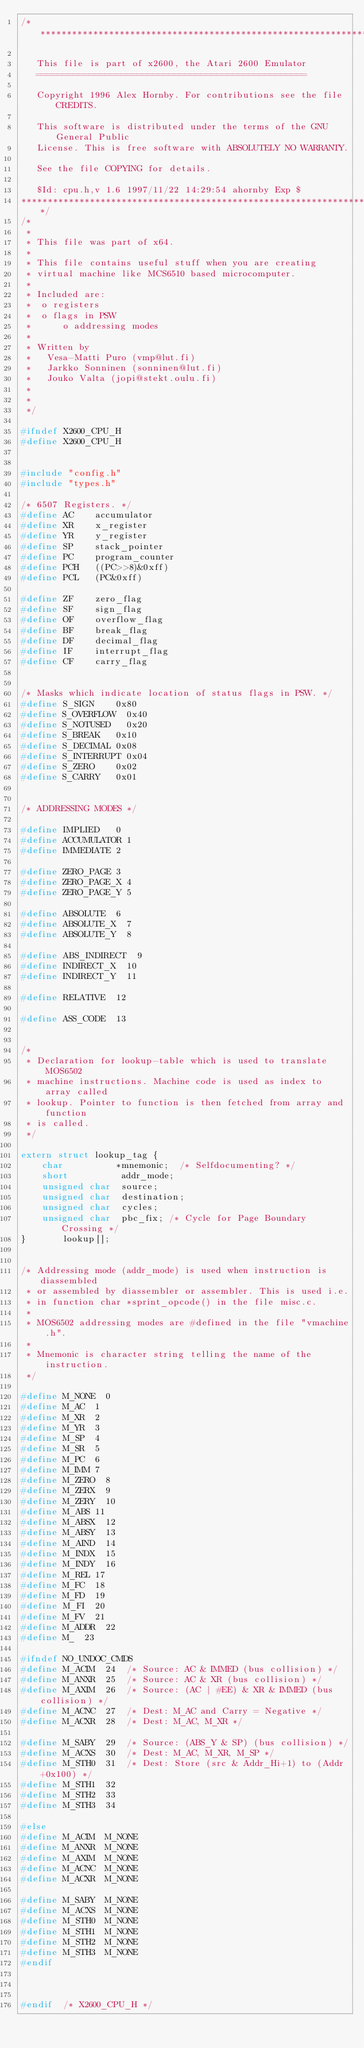Convert code to text. <code><loc_0><loc_0><loc_500><loc_500><_C_>/*****************************************************************************

   This file is part of x2600, the Atari 2600 Emulator
   ===================================================
   
   Copyright 1996 Alex Hornby. For contributions see the file CREDITS.

   This software is distributed under the terms of the GNU General Public
   License. This is free software with ABSOLUTELY NO WARRANTY.
   
   See the file COPYING for details.
   
   $Id: cpu.h,v 1.6 1997/11/22 14:29:54 ahornby Exp $
******************************************************************************/
/*
 *
 * This file was part of x64.
 *
 * This file contains useful stuff when you are creating
 * virtual machine like MCS6510 based microcomputer.
 *
 * Included are:
 *	o registers
 *	o flags in PSW
 *      o addressing modes
 *
 * Written by
 *   Vesa-Matti Puro (vmp@lut.fi)
 *   Jarkko Sonninen (sonninen@lut.fi)
 *   Jouko Valta (jopi@stekt.oulu.fi)
 *
 *
 */

#ifndef X2600_CPU_H
#define X2600_CPU_H


#include "config.h"
#include "types.h"

/* 6507 Registers. */
#define AC		accumulator
#define XR		x_register
#define YR		y_register
#define SP		stack_pointer
#define PC		program_counter
#define PCH		((PC>>8)&0xff)
#define PCL		(PC&0xff)

#define ZF		zero_flag
#define SF		sign_flag
#define OF		overflow_flag
#define BF		break_flag
#define DF		decimal_flag
#define IF		interrupt_flag
#define CF		carry_flag


/* Masks which indicate location of status flags in PSW. */
#define S_SIGN		0x80
#define S_OVERFLOW	0x40
#define S_NOTUSED 	0x20
#define S_BREAK		0x10
#define S_DECIMAL	0x08
#define S_INTERRUPT	0x04
#define S_ZERO		0x02
#define S_CARRY		0x01


/* ADDRESSING MODES */

#define IMPLIED		0
#define ACCUMULATOR	1
#define IMMEDIATE	2

#define ZERO_PAGE	3
#define ZERO_PAGE_X	4
#define ZERO_PAGE_Y	5

#define ABSOLUTE	6
#define ABSOLUTE_X	7
#define ABSOLUTE_Y	8

#define ABS_INDIRECT	9
#define INDIRECT_X	10
#define INDIRECT_Y	11

#define RELATIVE	12

#define ASS_CODE	13


/*
 * Declaration for lookup-table which is used to translate MOS6502
 * machine instructions. Machine code is used as index to array called
 * lookup. Pointer to function is then fetched from array and function
 * is called.
 */

extern struct lookup_tag {
    char          *mnemonic;	/* Selfdocumenting? */
    short          addr_mode;
    unsigned char  source;
    unsigned char  destination;
    unsigned char  cycles;
    unsigned char  pbc_fix;	/* Cycle for Page Boundary Crossing */
}       lookup[];


/* Addressing mode (addr_mode) is used when instruction is diassembled
 * or assembled by diassembler or assembler. This is used i.e.
 * in function char *sprint_opcode() in the file misc.c.
 *
 * MOS6502 addressing modes are #defined in the file "vmachine.h".
 *
 * Mnemonic is character string telling the name of the instruction.
 */

#define M_NONE	0
#define M_AC 	1
#define M_XR	2
#define M_YR	3
#define M_SP	4
#define M_SR	5
#define M_PC	6
#define M_IMM	7
#define M_ZERO	8
#define M_ZERX	9
#define M_ZERY	10
#define M_ABS	11
#define M_ABSX	12
#define M_ABSY	13
#define M_AIND	14
#define M_INDX	15
#define M_INDY	16
#define M_REL	17
#define M_FC	18
#define M_FD	19
#define M_FI	20
#define M_FV	21
#define M_ADDR	22
#define M_	23

#ifndef NO_UNDOC_CMDS
#define M_ACIM	24	/* Source: AC & IMMED (bus collision) */
#define M_ANXR	25	/* Source: AC & XR (bus collision) */
#define M_AXIM	26	/* Source: (AC | #EE) & XR & IMMED (bus collision) */
#define M_ACNC	27	/* Dest: M_AC and Carry = Negative */
#define M_ACXR	28	/* Dest: M_AC, M_XR */

#define M_SABY	29	/* Source: (ABS_Y & SP) (bus collision) */
#define M_ACXS	30	/* Dest: M_AC, M_XR, M_SP */
#define M_STH0	31	/* Dest: Store (src & Addr_Hi+1) to (Addr +0x100) */
#define M_STH1	32
#define M_STH2	33
#define M_STH3	34

#else
#define M_ACIM	M_NONE
#define M_ANXR	M_NONE
#define M_AXIM	M_NONE
#define M_ACNC	M_NONE
#define M_ACXR	M_NONE

#define M_SABY	M_NONE
#define M_ACXS	M_NONE
#define M_STH0	M_NONE
#define M_STH1	M_NONE
#define M_STH2	M_NONE
#define M_STH3	M_NONE
#endif



#endif  /* X2600_CPU_H */








</code> 